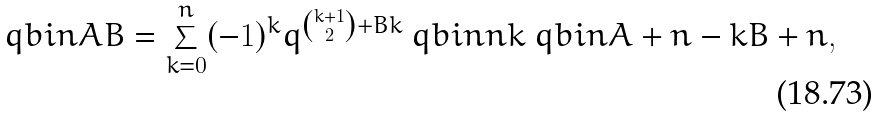<formula> <loc_0><loc_0><loc_500><loc_500>\ q b i n { A } { B } = \sum _ { k = 0 } ^ { n } ( - 1 ) ^ { k } q ^ { \binom { k + 1 } { 2 } + B k } \ q b i n { n } { k } \ q b i n { A + n - k } { B + n } ,</formula> 